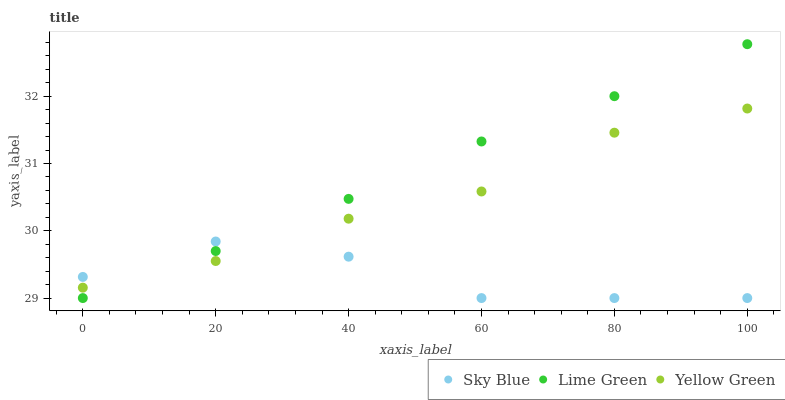Does Sky Blue have the minimum area under the curve?
Answer yes or no. Yes. Does Lime Green have the maximum area under the curve?
Answer yes or no. Yes. Does Yellow Green have the minimum area under the curve?
Answer yes or no. No. Does Yellow Green have the maximum area under the curve?
Answer yes or no. No. Is Lime Green the smoothest?
Answer yes or no. Yes. Is Sky Blue the roughest?
Answer yes or no. Yes. Is Yellow Green the smoothest?
Answer yes or no. No. Is Yellow Green the roughest?
Answer yes or no. No. Does Sky Blue have the lowest value?
Answer yes or no. Yes. Does Yellow Green have the lowest value?
Answer yes or no. No. Does Lime Green have the highest value?
Answer yes or no. Yes. Does Yellow Green have the highest value?
Answer yes or no. No. Does Yellow Green intersect Sky Blue?
Answer yes or no. Yes. Is Yellow Green less than Sky Blue?
Answer yes or no. No. Is Yellow Green greater than Sky Blue?
Answer yes or no. No. 